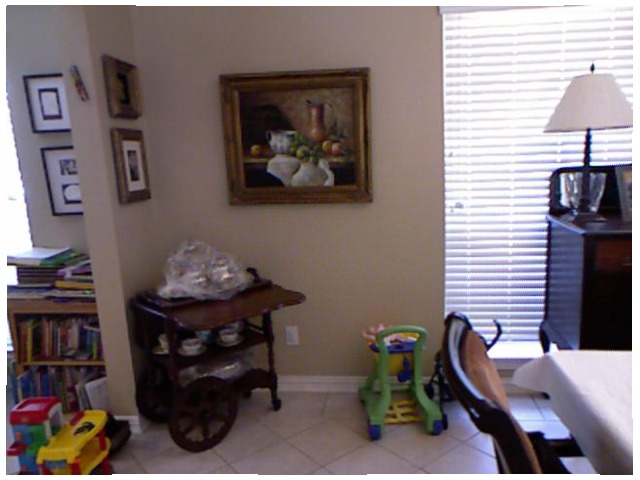<image>
Is there a painting under the blinds? No. The painting is not positioned under the blinds. The vertical relationship between these objects is different. Where is the photo frame in relation to the table lamp? Is it to the left of the table lamp? Yes. From this viewpoint, the photo frame is positioned to the left side relative to the table lamp. Is there a electric socket next to the wall? No. The electric socket is not positioned next to the wall. They are located in different areas of the scene. 